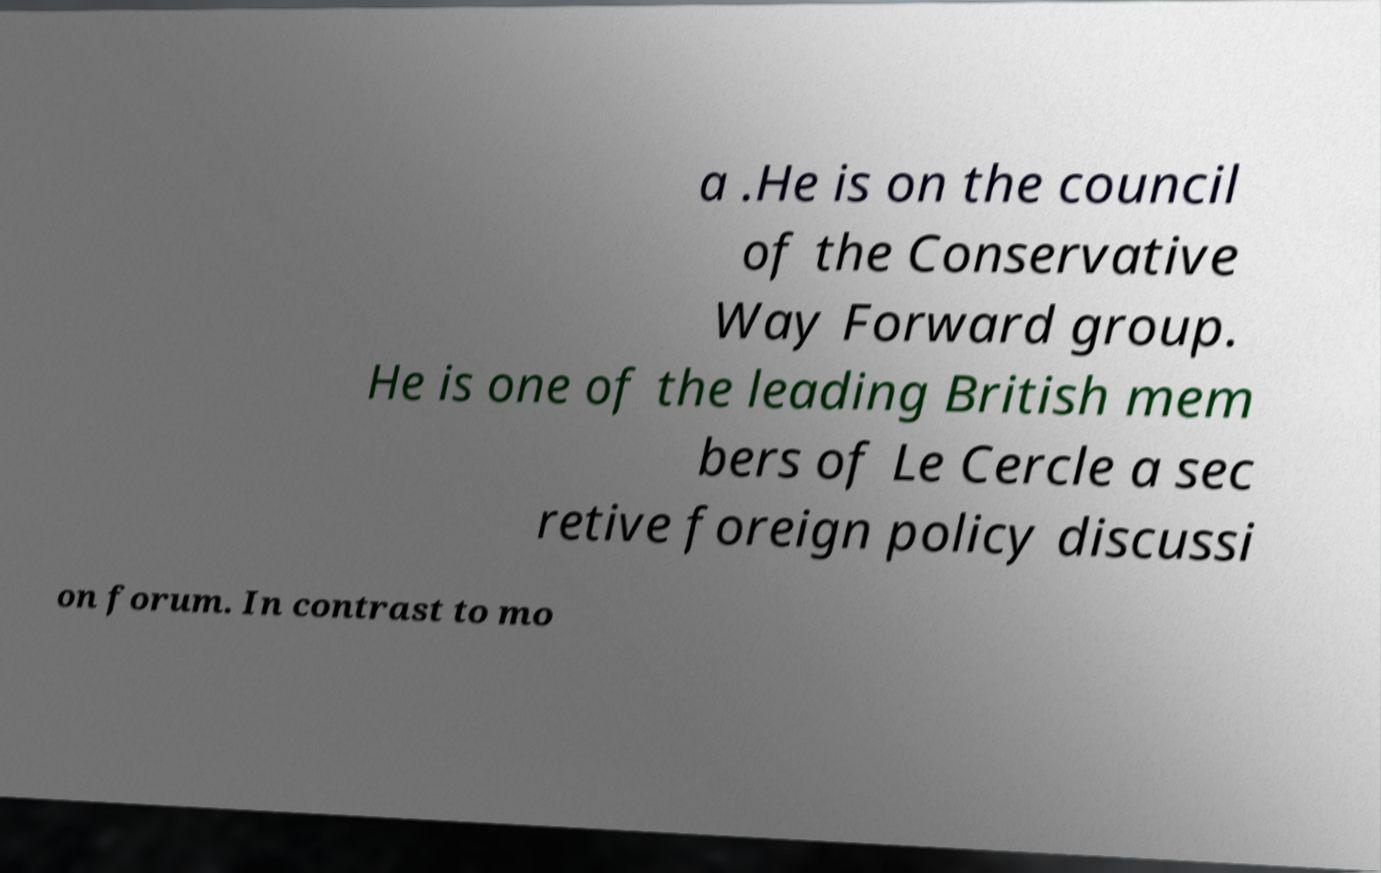For documentation purposes, I need the text within this image transcribed. Could you provide that? a .He is on the council of the Conservative Way Forward group. He is one of the leading British mem bers of Le Cercle a sec retive foreign policy discussi on forum. In contrast to mo 